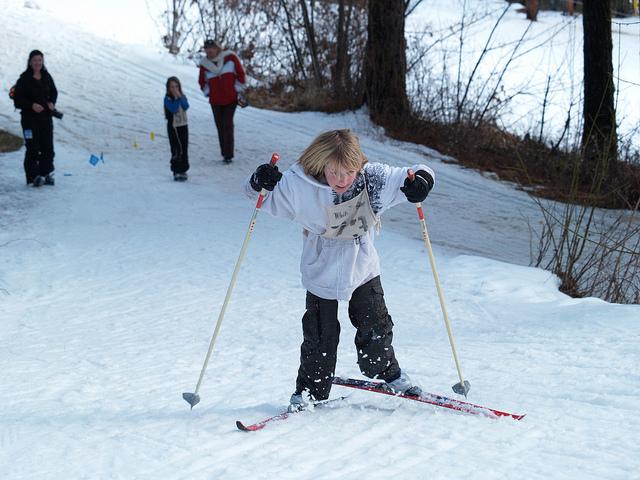Is the person happy?
Answer briefly. Yes. Is the skier wearing safety protection?
Answer briefly. No. What is the person doing?
Short answer required. Skiing. Which one of these people is learning?
Concise answer only. Child. Is this cross country skiing?
Keep it brief. Yes. Which child uses poles?
Keep it brief. Blonde kid. 